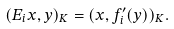<formula> <loc_0><loc_0><loc_500><loc_500>( E _ { i } x , y ) _ { K } = ( x , f _ { i } ^ { \prime } ( y ) ) _ { K } .</formula> 